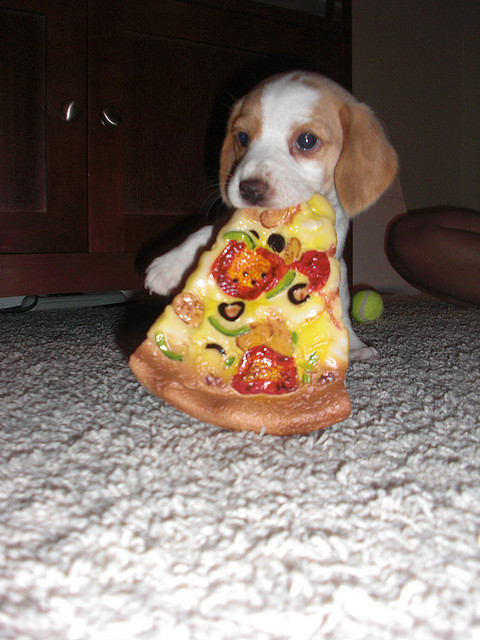<image>What type of breed is this dog? I am not sure about the dog's breed. It could be a beagle, lab, or pug. What type of breed is this dog? I am not sure what type of breed is this dog. It can be a beagle, lab, or pug. 